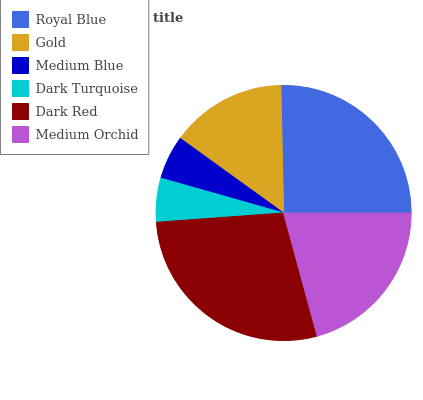Is Dark Turquoise the minimum?
Answer yes or no. Yes. Is Dark Red the maximum?
Answer yes or no. Yes. Is Gold the minimum?
Answer yes or no. No. Is Gold the maximum?
Answer yes or no. No. Is Royal Blue greater than Gold?
Answer yes or no. Yes. Is Gold less than Royal Blue?
Answer yes or no. Yes. Is Gold greater than Royal Blue?
Answer yes or no. No. Is Royal Blue less than Gold?
Answer yes or no. No. Is Medium Orchid the high median?
Answer yes or no. Yes. Is Gold the low median?
Answer yes or no. Yes. Is Royal Blue the high median?
Answer yes or no. No. Is Dark Turquoise the low median?
Answer yes or no. No. 